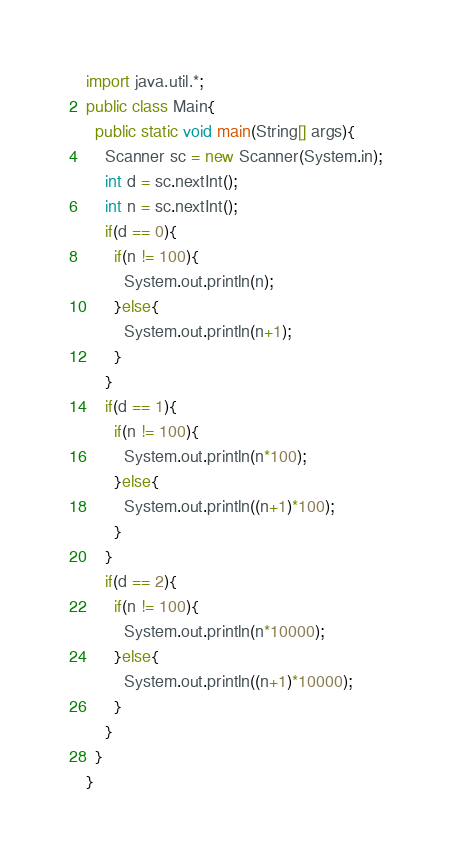Convert code to text. <code><loc_0><loc_0><loc_500><loc_500><_Java_>import java.util.*;
public class Main{
  public static void main(String[] args){
    Scanner sc = new Scanner(System.in);
    int d = sc.nextInt();
    int n = sc.nextInt();
    if(d == 0){
      if(n != 100){
        System.out.println(n);
      }else{
        System.out.println(n+1);
      }
    }
    if(d == 1){
      if(n != 100){
        System.out.println(n*100);
      }else{
        System.out.println((n+1)*100);
      }
    }
    if(d == 2){
      if(n != 100){
        System.out.println(n*10000);
      }else{
        System.out.println((n+1)*10000);
      }
    }
  }
}
</code> 